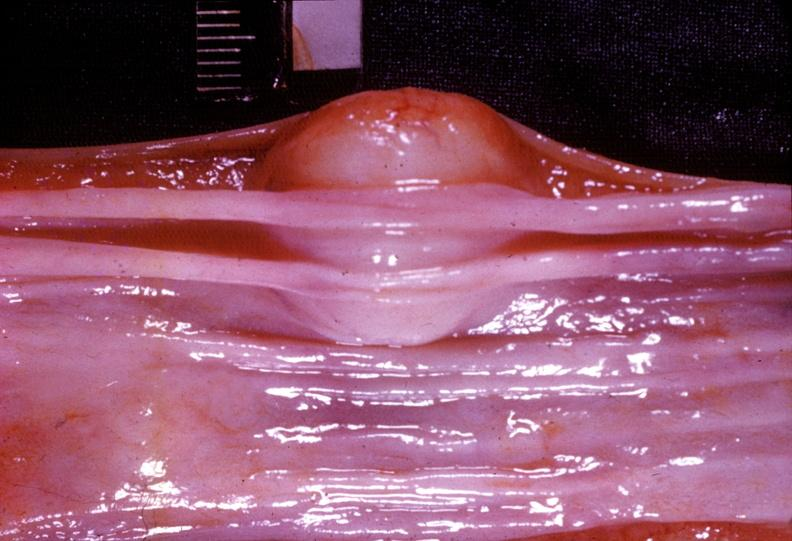what is present?
Answer the question using a single word or phrase. Gastrointestinal 